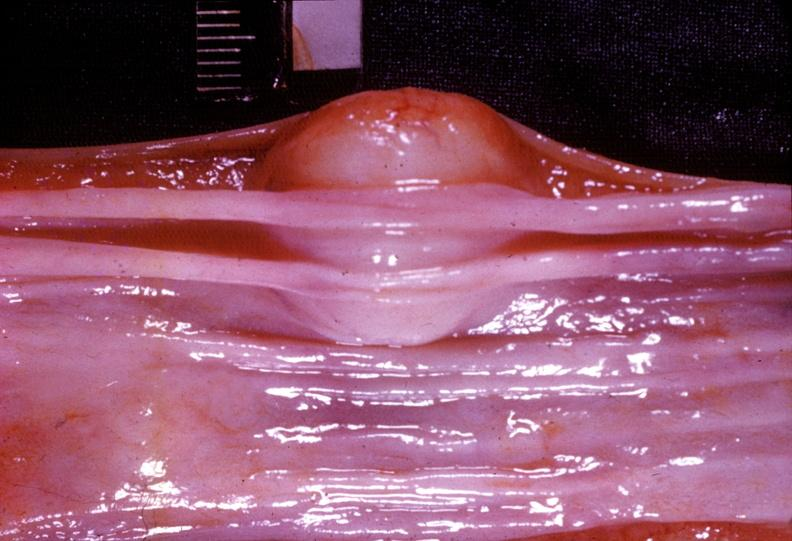what is present?
Answer the question using a single word or phrase. Gastrointestinal 